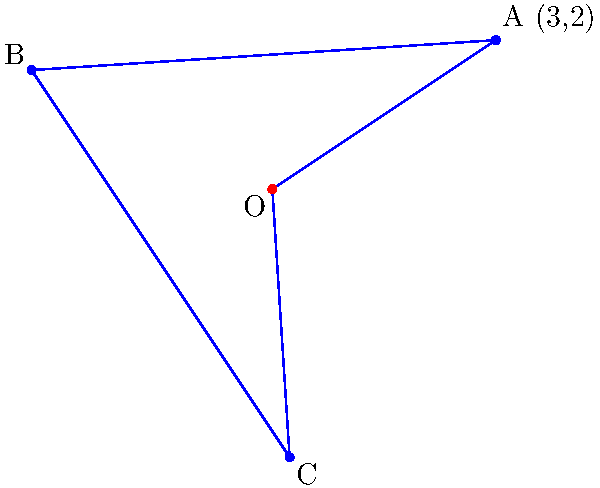The logo of a popular Japanese women's wrestler is an equilateral triangle. The initial position of one vertex of the logo is at point A(3,2) on a coordinate plane. The logo is rotated 120° and 240° counterclockwise around the origin O(0,0) to create points B and C respectively. What are the coordinates of point C? To find the coordinates of point C, we need to rotate point A(3,2) by 240° counterclockwise around the origin. We can use the rotation matrix to calculate this:

1) The rotation matrix for a counterclockwise rotation by angle θ is:
   $$R(\theta) = \begin{pmatrix} \cos\theta & -\sin\theta \\ \sin\theta & \cos\theta \end{pmatrix}$$

2) For 240°, we have:
   $$\cos 240° = -\frac{1}{2}, \sin 240° = -\frac{\sqrt{3}}{2}$$

3) Substituting these values:
   $$R(240°) = \begin{pmatrix} -\frac{1}{2} & \frac{\sqrt{3}}{2} \\ -\frac{\sqrt{3}}{2} & -\frac{1}{2} \end{pmatrix}$$

4) Multiplying this matrix by the coordinates of A(3,2):
   $$\begin{pmatrix} -\frac{1}{2} & \frac{\sqrt{3}}{2} \\ -\frac{\sqrt{3}}{2} & -\frac{1}{2} \end{pmatrix} \begin{pmatrix} 3 \\ 2 \end{pmatrix} = \begin{pmatrix} -\frac{3}{2} + \sqrt{3} \\ -\frac{3\sqrt{3}}{2} - 1 \end{pmatrix}$$

5) Simplifying:
   x-coordinate: $-\frac{3}{2} + \sqrt{3} \approx 0.23$
   y-coordinate: $-\frac{3\sqrt{3}}{2} - 1 \approx -3.60$

Therefore, the coordinates of point C are approximately (0.23, -3.60).
Answer: (0.23, -3.60) 